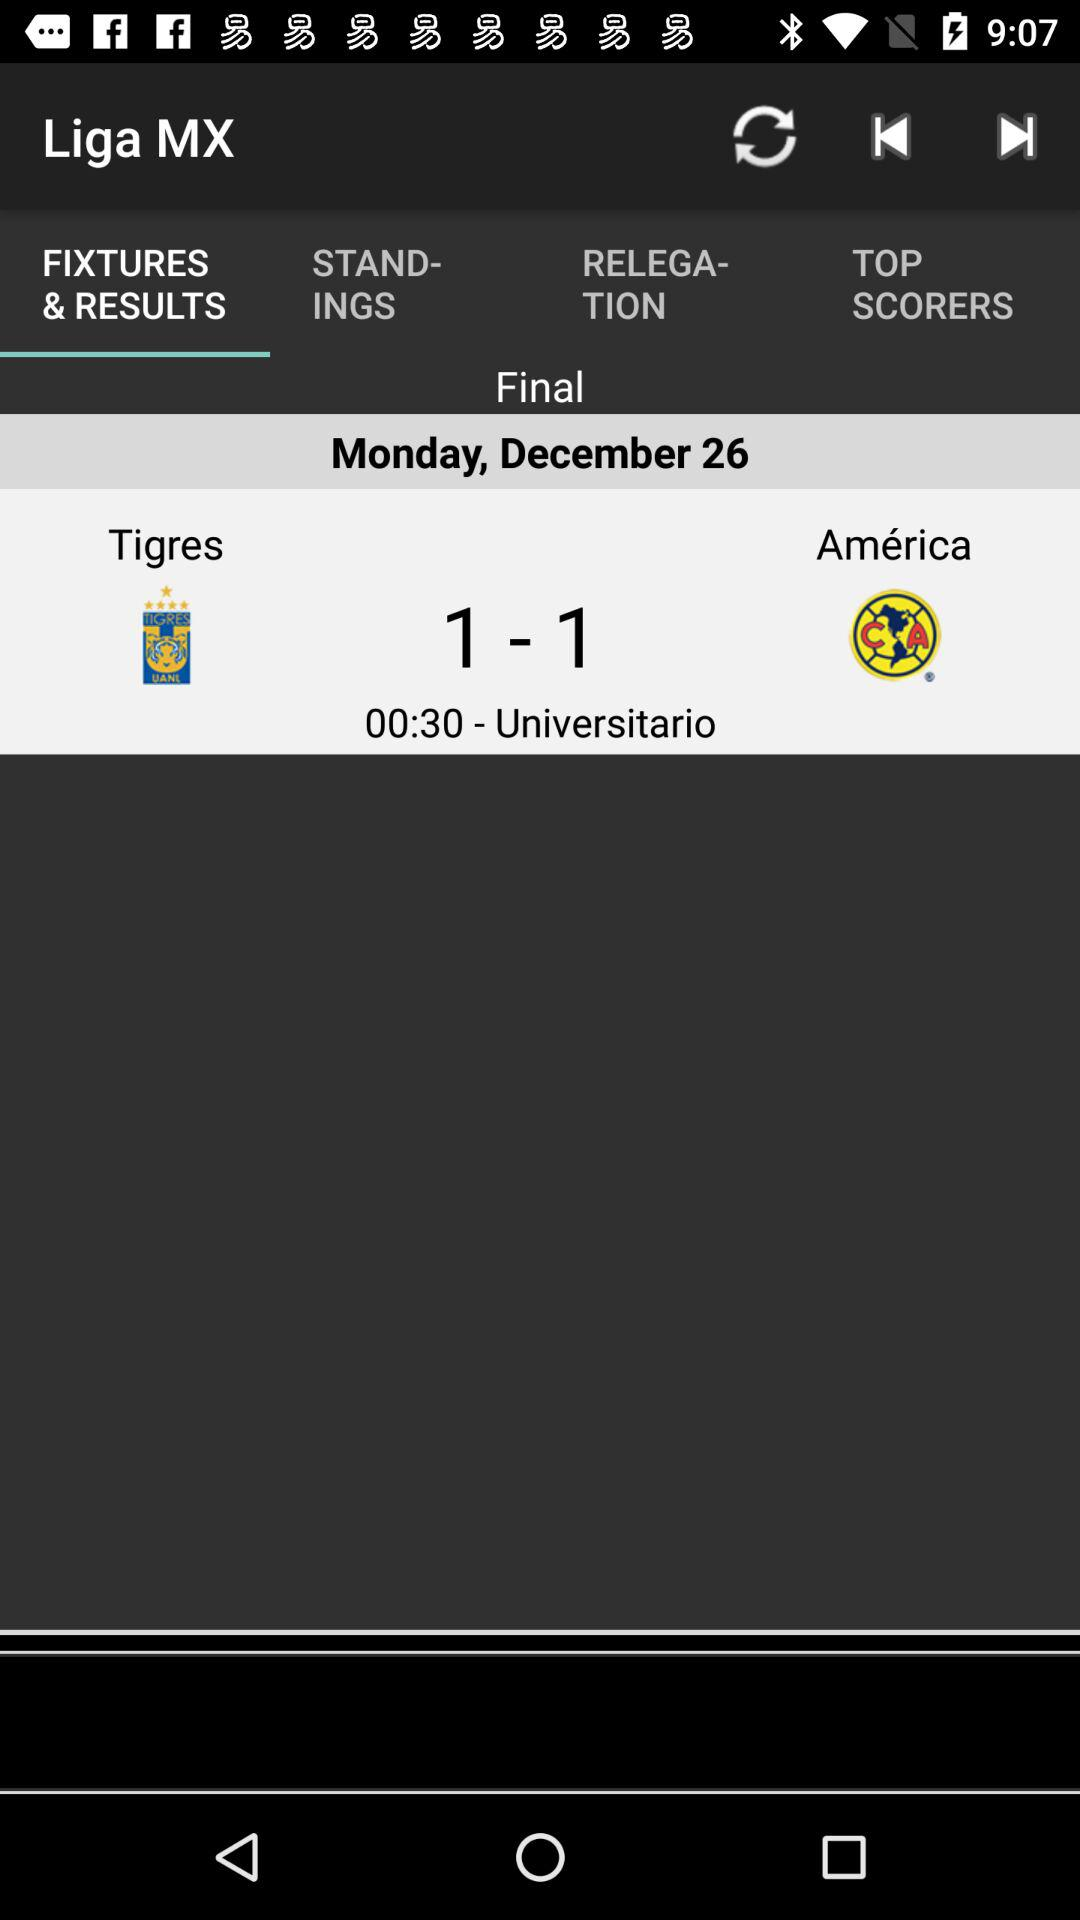Which tab is selected? The selected tab is "FIXTURES & RESULTS". 